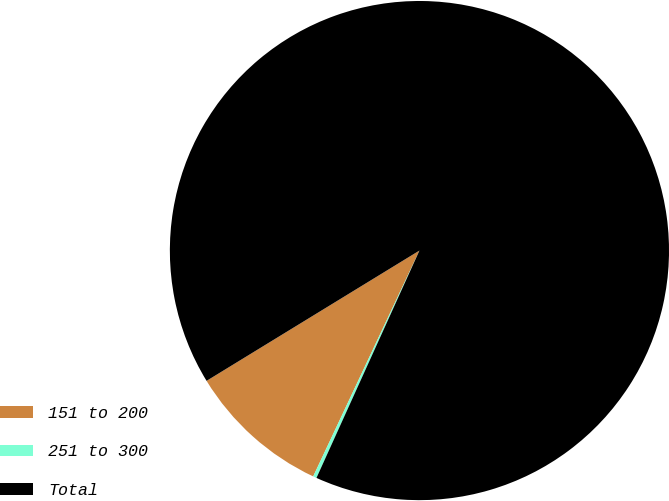Convert chart. <chart><loc_0><loc_0><loc_500><loc_500><pie_chart><fcel>151 to 200<fcel>251 to 300<fcel>Total<nl><fcel>9.26%<fcel>0.23%<fcel>90.51%<nl></chart> 